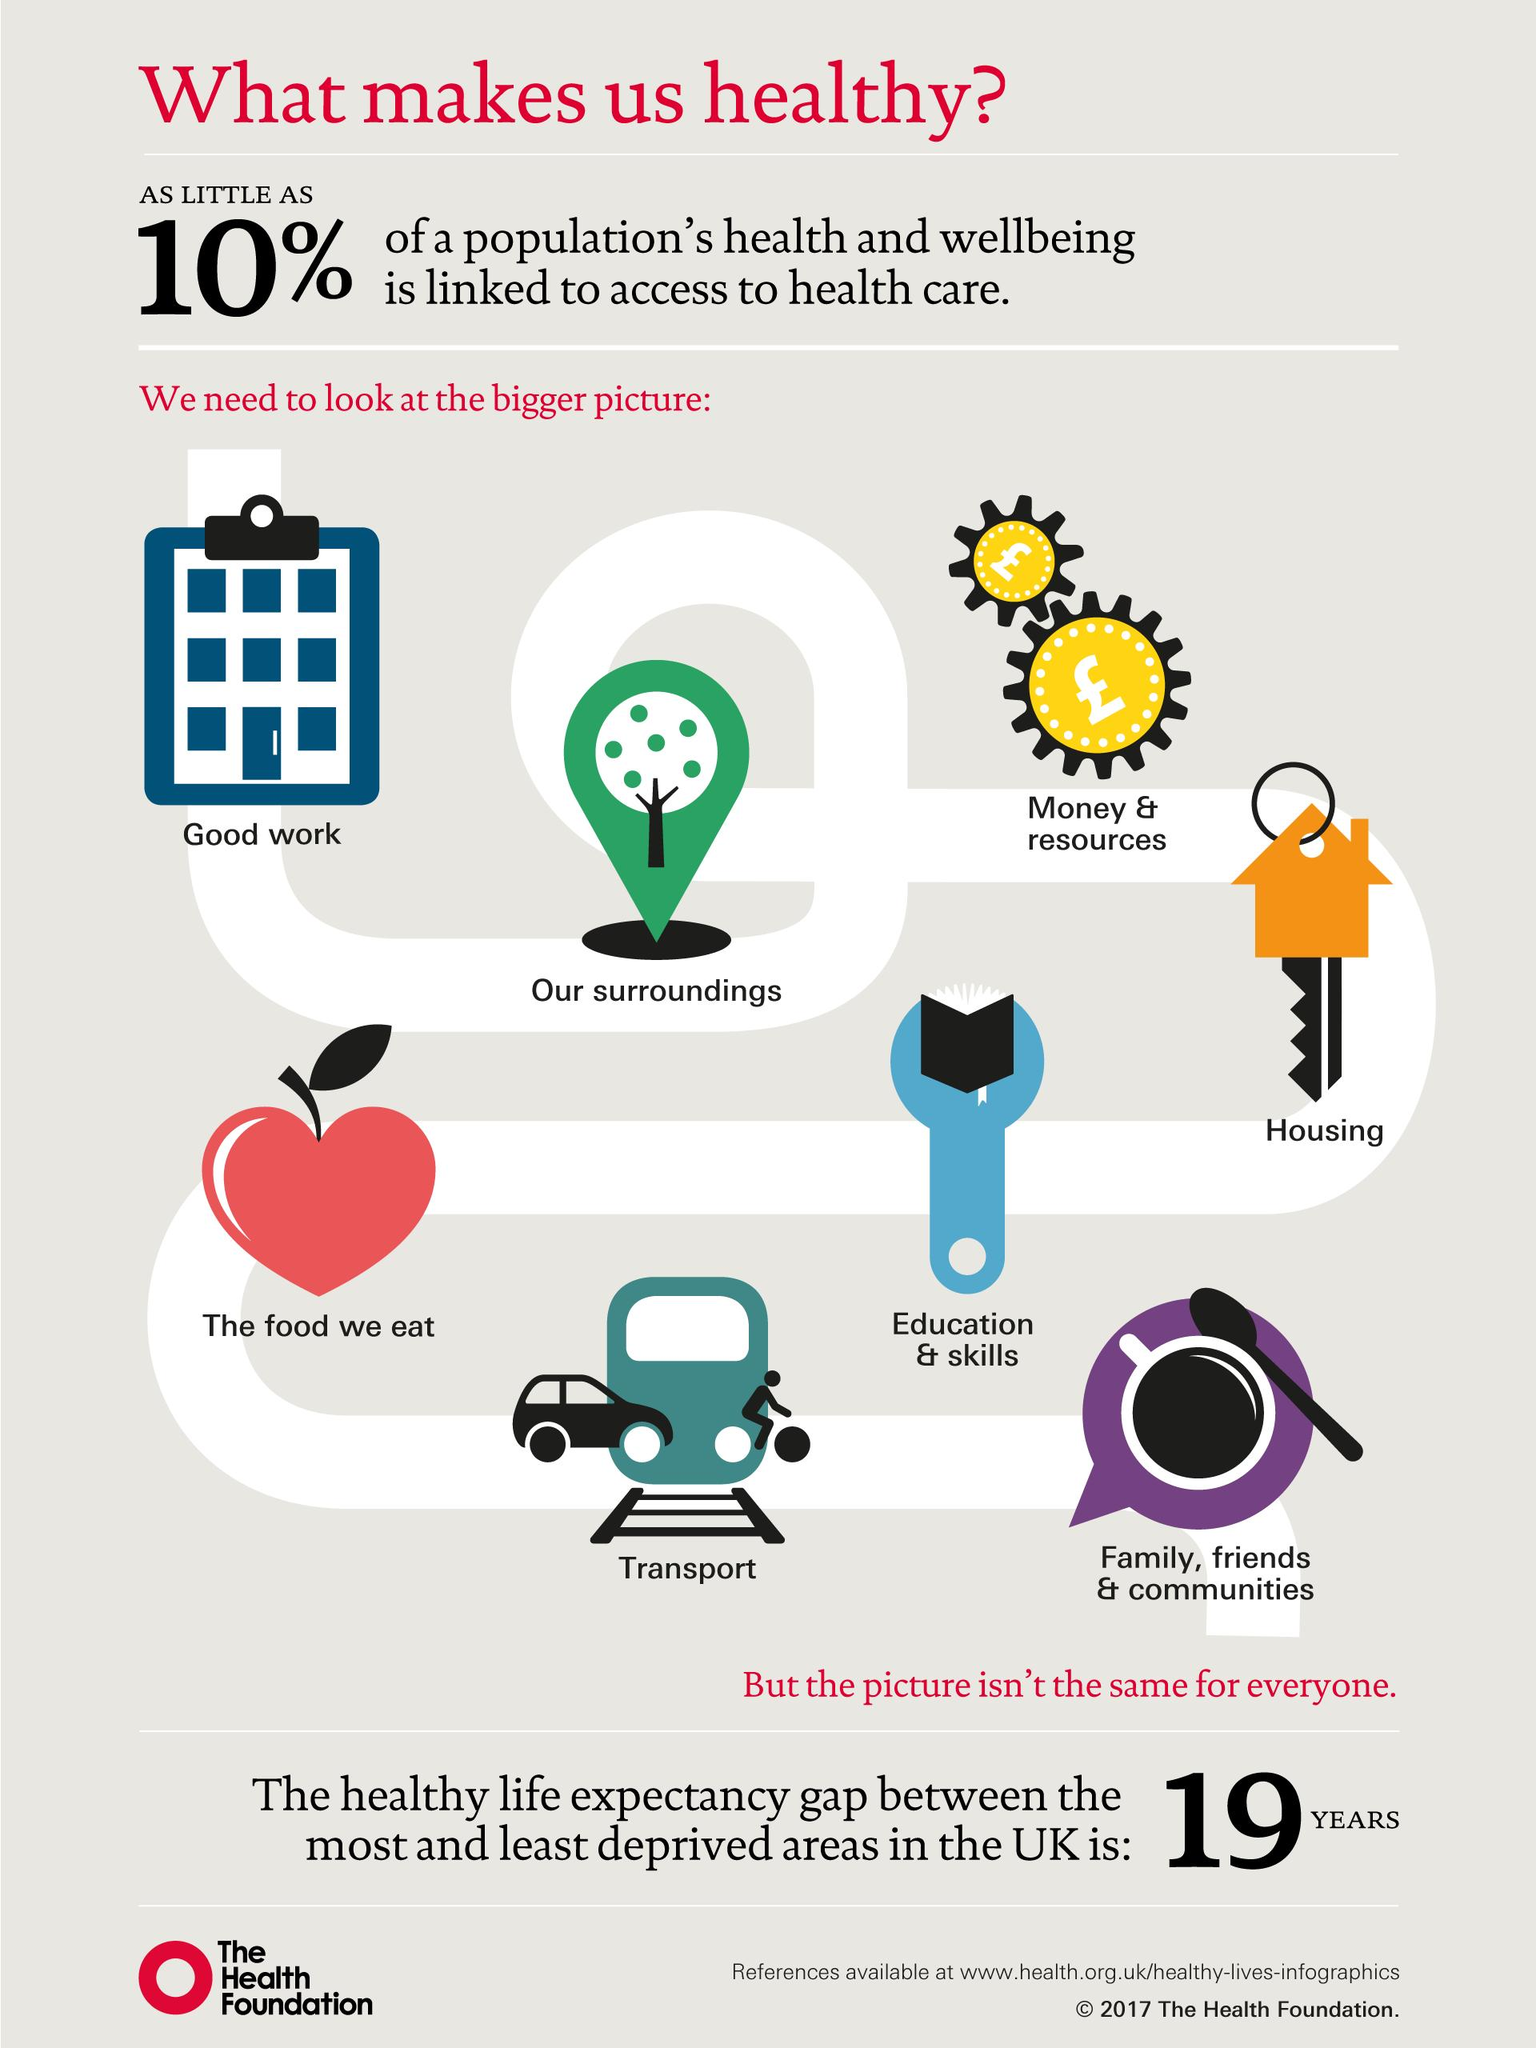Identify some key points in this picture. According to recent data, less than 10% of the population's overall health and well-being is directly linked to access to health care. The population's health is affected by multiple factors, including genetics, environment, lifestyle choices, access to healthcare, socioeconomic status, and more. 